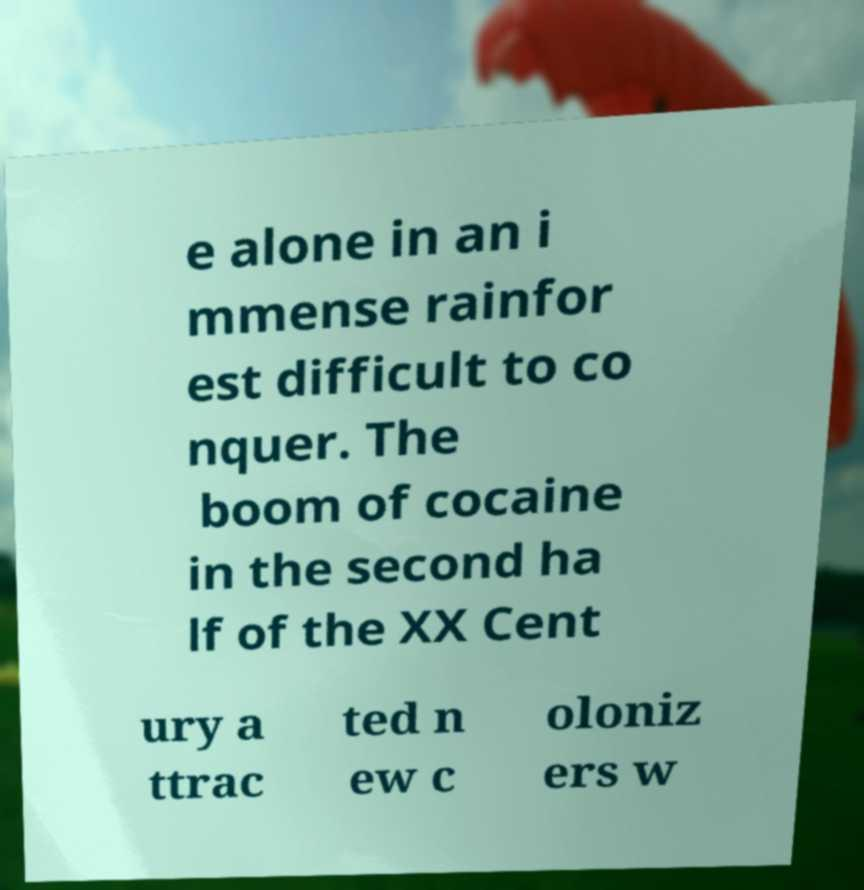Please read and relay the text visible in this image. What does it say? e alone in an i mmense rainfor est difficult to co nquer. The boom of cocaine in the second ha lf of the XX Cent ury a ttrac ted n ew c oloniz ers w 